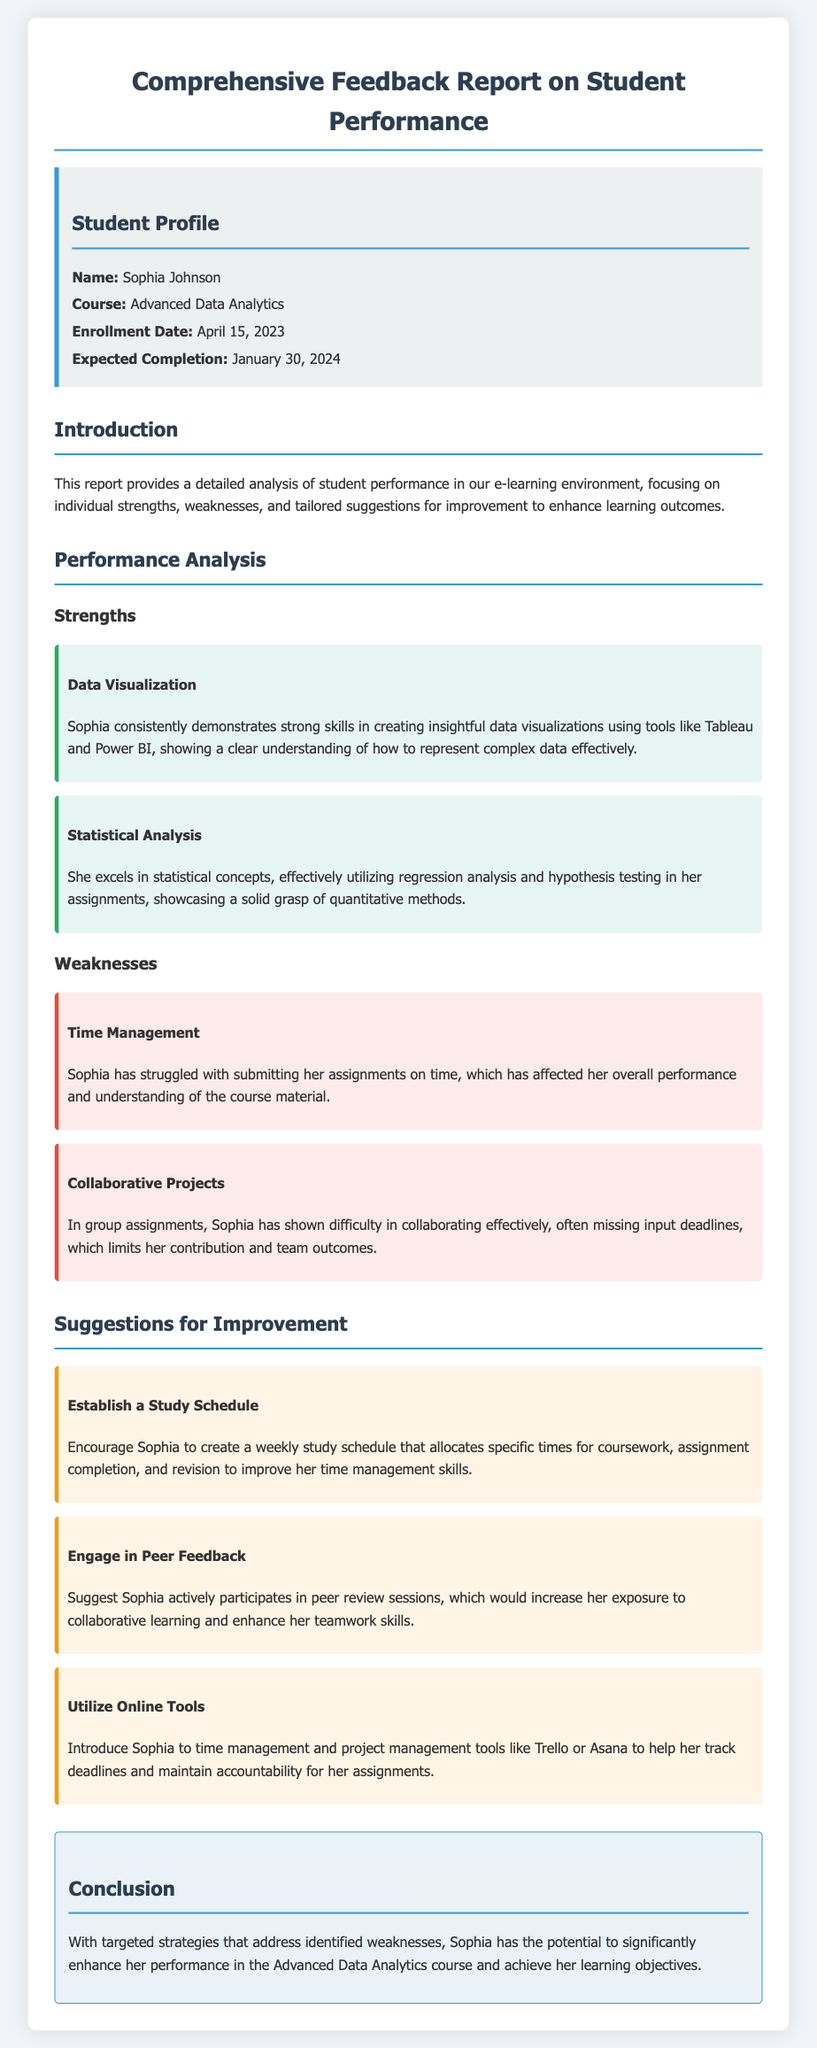What is the student's name? The student's name is stated in the profile section of the document.
Answer: Sophia Johnson What course is Sophia enrolled in? The course name is mentioned in the student profile.
Answer: Advanced Data Analytics When is Sophia's expected completion date? The expected completion date is provided in the student profile.
Answer: January 30, 2024 What is one of Sophia's strengths? The strengths are listed under the performance analysis section of the document.
Answer: Data Visualization What weakness is mentioned regarding Sophia's collaborative projects? The weakness is detailed under the weaknesses section, which describes her challenges in team settings.
Answer: Difficulty in collaborating effectively What suggestion is given to help with time management? Suggestions for improvement are outlined in the corresponding section, offering strategies for growth.
Answer: Establish a Study Schedule Which tool is suggested to help Sophia track deadlines? The document suggests a specific type of tool in the suggestions for improvement.
Answer: Trello or Asana What is the focus of this report? The introduction section describes the overall aim of the report.
Answer: Detailed analysis of student performance What is the conclusion regarding Sophia's potential? The conclusion summarizes the insights gained from the report and reflects on her potential.
Answer: Enhance her performance in the Advanced Data Analytics course 